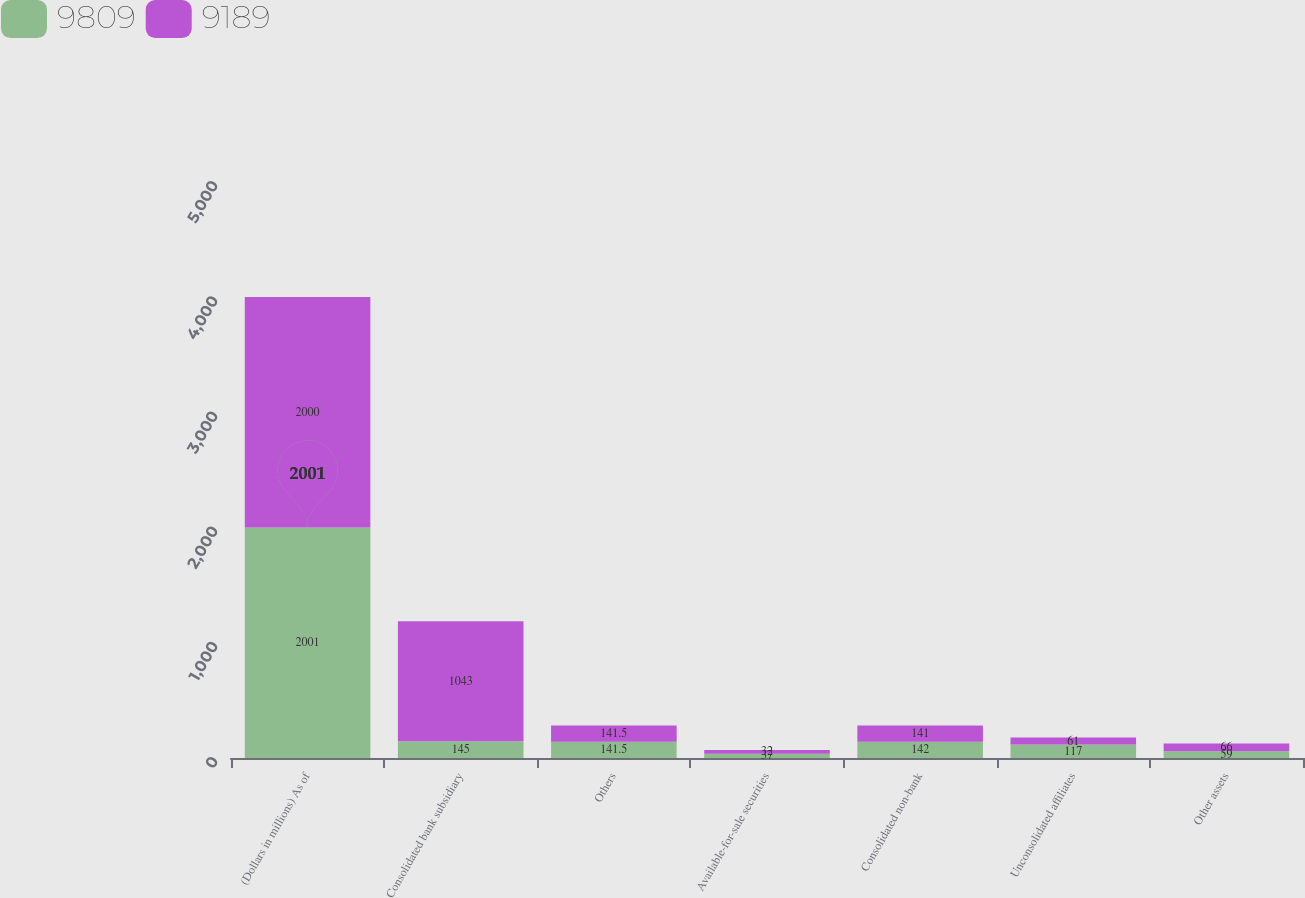Convert chart to OTSL. <chart><loc_0><loc_0><loc_500><loc_500><stacked_bar_chart><ecel><fcel>(Dollars in millions) As of<fcel>Consolidated bank subsidiary<fcel>Others<fcel>Available-for-sale securities<fcel>Consolidated non-bank<fcel>Unconsolidated affiliates<fcel>Other assets<nl><fcel>9809<fcel>2001<fcel>145<fcel>141.5<fcel>37<fcel>142<fcel>117<fcel>59<nl><fcel>9189<fcel>2000<fcel>1043<fcel>141.5<fcel>32<fcel>141<fcel>61<fcel>66<nl></chart> 